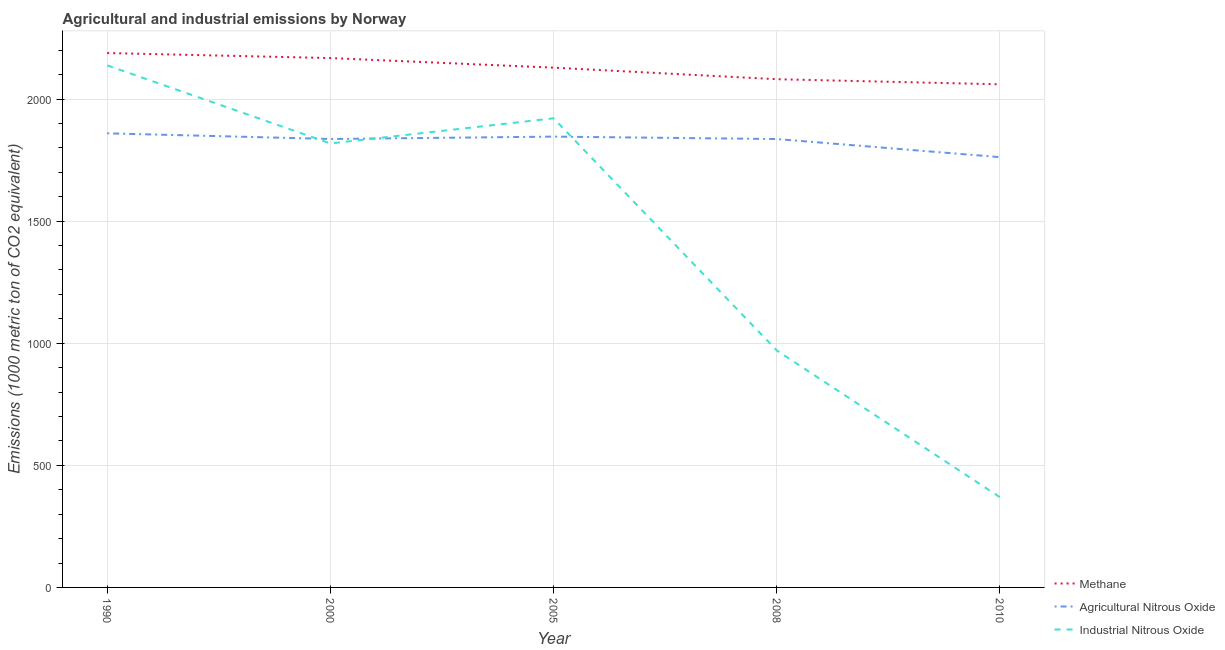Does the line corresponding to amount of agricultural nitrous oxide emissions intersect with the line corresponding to amount of methane emissions?
Provide a short and direct response. No. What is the amount of methane emissions in 2000?
Offer a terse response. 2167.9. Across all years, what is the maximum amount of industrial nitrous oxide emissions?
Your answer should be compact. 2138. Across all years, what is the minimum amount of methane emissions?
Give a very brief answer. 2060.5. In which year was the amount of industrial nitrous oxide emissions maximum?
Your response must be concise. 1990. In which year was the amount of methane emissions minimum?
Ensure brevity in your answer.  2010. What is the total amount of industrial nitrous oxide emissions in the graph?
Give a very brief answer. 7217.1. What is the difference between the amount of methane emissions in 1990 and that in 2005?
Your response must be concise. 59.9. What is the difference between the amount of agricultural nitrous oxide emissions in 2010 and the amount of methane emissions in 2000?
Your answer should be very brief. -405.8. What is the average amount of agricultural nitrous oxide emissions per year?
Your answer should be very brief. 1828.16. In the year 2000, what is the difference between the amount of industrial nitrous oxide emissions and amount of agricultural nitrous oxide emissions?
Your answer should be very brief. -18.3. In how many years, is the amount of agricultural nitrous oxide emissions greater than 400 metric ton?
Provide a succinct answer. 5. What is the ratio of the amount of industrial nitrous oxide emissions in 2005 to that in 2008?
Offer a very short reply. 1.98. Is the amount of methane emissions in 2005 less than that in 2010?
Your answer should be compact. No. What is the difference between the highest and the second highest amount of agricultural nitrous oxide emissions?
Your response must be concise. 13.5. What is the difference between the highest and the lowest amount of agricultural nitrous oxide emissions?
Offer a terse response. 97.6. Is it the case that in every year, the sum of the amount of methane emissions and amount of agricultural nitrous oxide emissions is greater than the amount of industrial nitrous oxide emissions?
Offer a very short reply. Yes. Does the graph contain grids?
Your response must be concise. Yes. Where does the legend appear in the graph?
Your answer should be compact. Bottom right. How many legend labels are there?
Provide a short and direct response. 3. How are the legend labels stacked?
Keep it short and to the point. Vertical. What is the title of the graph?
Offer a terse response. Agricultural and industrial emissions by Norway. What is the label or title of the Y-axis?
Your answer should be compact. Emissions (1000 metric ton of CO2 equivalent). What is the Emissions (1000 metric ton of CO2 equivalent) in Methane in 1990?
Ensure brevity in your answer.  2188.5. What is the Emissions (1000 metric ton of CO2 equivalent) of Agricultural Nitrous Oxide in 1990?
Offer a terse response. 1859.7. What is the Emissions (1000 metric ton of CO2 equivalent) of Industrial Nitrous Oxide in 1990?
Provide a succinct answer. 2138. What is the Emissions (1000 metric ton of CO2 equivalent) of Methane in 2000?
Keep it short and to the point. 2167.9. What is the Emissions (1000 metric ton of CO2 equivalent) in Agricultural Nitrous Oxide in 2000?
Offer a terse response. 1836.5. What is the Emissions (1000 metric ton of CO2 equivalent) of Industrial Nitrous Oxide in 2000?
Provide a short and direct response. 1818.2. What is the Emissions (1000 metric ton of CO2 equivalent) of Methane in 2005?
Offer a very short reply. 2128.6. What is the Emissions (1000 metric ton of CO2 equivalent) in Agricultural Nitrous Oxide in 2005?
Offer a terse response. 1846.2. What is the Emissions (1000 metric ton of CO2 equivalent) in Industrial Nitrous Oxide in 2005?
Make the answer very short. 1921.2. What is the Emissions (1000 metric ton of CO2 equivalent) in Methane in 2008?
Your answer should be very brief. 2081.3. What is the Emissions (1000 metric ton of CO2 equivalent) of Agricultural Nitrous Oxide in 2008?
Provide a short and direct response. 1836.3. What is the Emissions (1000 metric ton of CO2 equivalent) in Industrial Nitrous Oxide in 2008?
Offer a terse response. 970.4. What is the Emissions (1000 metric ton of CO2 equivalent) of Methane in 2010?
Offer a terse response. 2060.5. What is the Emissions (1000 metric ton of CO2 equivalent) in Agricultural Nitrous Oxide in 2010?
Offer a very short reply. 1762.1. What is the Emissions (1000 metric ton of CO2 equivalent) in Industrial Nitrous Oxide in 2010?
Your answer should be very brief. 369.3. Across all years, what is the maximum Emissions (1000 metric ton of CO2 equivalent) in Methane?
Ensure brevity in your answer.  2188.5. Across all years, what is the maximum Emissions (1000 metric ton of CO2 equivalent) of Agricultural Nitrous Oxide?
Give a very brief answer. 1859.7. Across all years, what is the maximum Emissions (1000 metric ton of CO2 equivalent) in Industrial Nitrous Oxide?
Give a very brief answer. 2138. Across all years, what is the minimum Emissions (1000 metric ton of CO2 equivalent) of Methane?
Your response must be concise. 2060.5. Across all years, what is the minimum Emissions (1000 metric ton of CO2 equivalent) in Agricultural Nitrous Oxide?
Provide a succinct answer. 1762.1. Across all years, what is the minimum Emissions (1000 metric ton of CO2 equivalent) in Industrial Nitrous Oxide?
Provide a succinct answer. 369.3. What is the total Emissions (1000 metric ton of CO2 equivalent) in Methane in the graph?
Provide a succinct answer. 1.06e+04. What is the total Emissions (1000 metric ton of CO2 equivalent) in Agricultural Nitrous Oxide in the graph?
Offer a terse response. 9140.8. What is the total Emissions (1000 metric ton of CO2 equivalent) in Industrial Nitrous Oxide in the graph?
Offer a very short reply. 7217.1. What is the difference between the Emissions (1000 metric ton of CO2 equivalent) of Methane in 1990 and that in 2000?
Provide a succinct answer. 20.6. What is the difference between the Emissions (1000 metric ton of CO2 equivalent) in Agricultural Nitrous Oxide in 1990 and that in 2000?
Your answer should be compact. 23.2. What is the difference between the Emissions (1000 metric ton of CO2 equivalent) in Industrial Nitrous Oxide in 1990 and that in 2000?
Ensure brevity in your answer.  319.8. What is the difference between the Emissions (1000 metric ton of CO2 equivalent) of Methane in 1990 and that in 2005?
Keep it short and to the point. 59.9. What is the difference between the Emissions (1000 metric ton of CO2 equivalent) of Industrial Nitrous Oxide in 1990 and that in 2005?
Your answer should be compact. 216.8. What is the difference between the Emissions (1000 metric ton of CO2 equivalent) of Methane in 1990 and that in 2008?
Ensure brevity in your answer.  107.2. What is the difference between the Emissions (1000 metric ton of CO2 equivalent) of Agricultural Nitrous Oxide in 1990 and that in 2008?
Make the answer very short. 23.4. What is the difference between the Emissions (1000 metric ton of CO2 equivalent) of Industrial Nitrous Oxide in 1990 and that in 2008?
Give a very brief answer. 1167.6. What is the difference between the Emissions (1000 metric ton of CO2 equivalent) of Methane in 1990 and that in 2010?
Make the answer very short. 128. What is the difference between the Emissions (1000 metric ton of CO2 equivalent) in Agricultural Nitrous Oxide in 1990 and that in 2010?
Give a very brief answer. 97.6. What is the difference between the Emissions (1000 metric ton of CO2 equivalent) of Industrial Nitrous Oxide in 1990 and that in 2010?
Offer a very short reply. 1768.7. What is the difference between the Emissions (1000 metric ton of CO2 equivalent) in Methane in 2000 and that in 2005?
Ensure brevity in your answer.  39.3. What is the difference between the Emissions (1000 metric ton of CO2 equivalent) of Industrial Nitrous Oxide in 2000 and that in 2005?
Provide a short and direct response. -103. What is the difference between the Emissions (1000 metric ton of CO2 equivalent) in Methane in 2000 and that in 2008?
Offer a terse response. 86.6. What is the difference between the Emissions (1000 metric ton of CO2 equivalent) of Industrial Nitrous Oxide in 2000 and that in 2008?
Offer a very short reply. 847.8. What is the difference between the Emissions (1000 metric ton of CO2 equivalent) in Methane in 2000 and that in 2010?
Offer a very short reply. 107.4. What is the difference between the Emissions (1000 metric ton of CO2 equivalent) of Agricultural Nitrous Oxide in 2000 and that in 2010?
Make the answer very short. 74.4. What is the difference between the Emissions (1000 metric ton of CO2 equivalent) of Industrial Nitrous Oxide in 2000 and that in 2010?
Provide a succinct answer. 1448.9. What is the difference between the Emissions (1000 metric ton of CO2 equivalent) of Methane in 2005 and that in 2008?
Give a very brief answer. 47.3. What is the difference between the Emissions (1000 metric ton of CO2 equivalent) in Agricultural Nitrous Oxide in 2005 and that in 2008?
Offer a very short reply. 9.9. What is the difference between the Emissions (1000 metric ton of CO2 equivalent) of Industrial Nitrous Oxide in 2005 and that in 2008?
Offer a terse response. 950.8. What is the difference between the Emissions (1000 metric ton of CO2 equivalent) in Methane in 2005 and that in 2010?
Provide a succinct answer. 68.1. What is the difference between the Emissions (1000 metric ton of CO2 equivalent) of Agricultural Nitrous Oxide in 2005 and that in 2010?
Your answer should be compact. 84.1. What is the difference between the Emissions (1000 metric ton of CO2 equivalent) of Industrial Nitrous Oxide in 2005 and that in 2010?
Give a very brief answer. 1551.9. What is the difference between the Emissions (1000 metric ton of CO2 equivalent) in Methane in 2008 and that in 2010?
Give a very brief answer. 20.8. What is the difference between the Emissions (1000 metric ton of CO2 equivalent) in Agricultural Nitrous Oxide in 2008 and that in 2010?
Ensure brevity in your answer.  74.2. What is the difference between the Emissions (1000 metric ton of CO2 equivalent) in Industrial Nitrous Oxide in 2008 and that in 2010?
Your answer should be very brief. 601.1. What is the difference between the Emissions (1000 metric ton of CO2 equivalent) of Methane in 1990 and the Emissions (1000 metric ton of CO2 equivalent) of Agricultural Nitrous Oxide in 2000?
Your answer should be compact. 352. What is the difference between the Emissions (1000 metric ton of CO2 equivalent) in Methane in 1990 and the Emissions (1000 metric ton of CO2 equivalent) in Industrial Nitrous Oxide in 2000?
Ensure brevity in your answer.  370.3. What is the difference between the Emissions (1000 metric ton of CO2 equivalent) in Agricultural Nitrous Oxide in 1990 and the Emissions (1000 metric ton of CO2 equivalent) in Industrial Nitrous Oxide in 2000?
Ensure brevity in your answer.  41.5. What is the difference between the Emissions (1000 metric ton of CO2 equivalent) in Methane in 1990 and the Emissions (1000 metric ton of CO2 equivalent) in Agricultural Nitrous Oxide in 2005?
Offer a terse response. 342.3. What is the difference between the Emissions (1000 metric ton of CO2 equivalent) of Methane in 1990 and the Emissions (1000 metric ton of CO2 equivalent) of Industrial Nitrous Oxide in 2005?
Your answer should be compact. 267.3. What is the difference between the Emissions (1000 metric ton of CO2 equivalent) of Agricultural Nitrous Oxide in 1990 and the Emissions (1000 metric ton of CO2 equivalent) of Industrial Nitrous Oxide in 2005?
Make the answer very short. -61.5. What is the difference between the Emissions (1000 metric ton of CO2 equivalent) in Methane in 1990 and the Emissions (1000 metric ton of CO2 equivalent) in Agricultural Nitrous Oxide in 2008?
Provide a short and direct response. 352.2. What is the difference between the Emissions (1000 metric ton of CO2 equivalent) of Methane in 1990 and the Emissions (1000 metric ton of CO2 equivalent) of Industrial Nitrous Oxide in 2008?
Provide a short and direct response. 1218.1. What is the difference between the Emissions (1000 metric ton of CO2 equivalent) of Agricultural Nitrous Oxide in 1990 and the Emissions (1000 metric ton of CO2 equivalent) of Industrial Nitrous Oxide in 2008?
Ensure brevity in your answer.  889.3. What is the difference between the Emissions (1000 metric ton of CO2 equivalent) of Methane in 1990 and the Emissions (1000 metric ton of CO2 equivalent) of Agricultural Nitrous Oxide in 2010?
Offer a very short reply. 426.4. What is the difference between the Emissions (1000 metric ton of CO2 equivalent) of Methane in 1990 and the Emissions (1000 metric ton of CO2 equivalent) of Industrial Nitrous Oxide in 2010?
Your response must be concise. 1819.2. What is the difference between the Emissions (1000 metric ton of CO2 equivalent) in Agricultural Nitrous Oxide in 1990 and the Emissions (1000 metric ton of CO2 equivalent) in Industrial Nitrous Oxide in 2010?
Your answer should be compact. 1490.4. What is the difference between the Emissions (1000 metric ton of CO2 equivalent) in Methane in 2000 and the Emissions (1000 metric ton of CO2 equivalent) in Agricultural Nitrous Oxide in 2005?
Your answer should be very brief. 321.7. What is the difference between the Emissions (1000 metric ton of CO2 equivalent) of Methane in 2000 and the Emissions (1000 metric ton of CO2 equivalent) of Industrial Nitrous Oxide in 2005?
Provide a short and direct response. 246.7. What is the difference between the Emissions (1000 metric ton of CO2 equivalent) of Agricultural Nitrous Oxide in 2000 and the Emissions (1000 metric ton of CO2 equivalent) of Industrial Nitrous Oxide in 2005?
Ensure brevity in your answer.  -84.7. What is the difference between the Emissions (1000 metric ton of CO2 equivalent) in Methane in 2000 and the Emissions (1000 metric ton of CO2 equivalent) in Agricultural Nitrous Oxide in 2008?
Your answer should be compact. 331.6. What is the difference between the Emissions (1000 metric ton of CO2 equivalent) of Methane in 2000 and the Emissions (1000 metric ton of CO2 equivalent) of Industrial Nitrous Oxide in 2008?
Give a very brief answer. 1197.5. What is the difference between the Emissions (1000 metric ton of CO2 equivalent) in Agricultural Nitrous Oxide in 2000 and the Emissions (1000 metric ton of CO2 equivalent) in Industrial Nitrous Oxide in 2008?
Provide a short and direct response. 866.1. What is the difference between the Emissions (1000 metric ton of CO2 equivalent) of Methane in 2000 and the Emissions (1000 metric ton of CO2 equivalent) of Agricultural Nitrous Oxide in 2010?
Keep it short and to the point. 405.8. What is the difference between the Emissions (1000 metric ton of CO2 equivalent) of Methane in 2000 and the Emissions (1000 metric ton of CO2 equivalent) of Industrial Nitrous Oxide in 2010?
Your answer should be very brief. 1798.6. What is the difference between the Emissions (1000 metric ton of CO2 equivalent) of Agricultural Nitrous Oxide in 2000 and the Emissions (1000 metric ton of CO2 equivalent) of Industrial Nitrous Oxide in 2010?
Offer a terse response. 1467.2. What is the difference between the Emissions (1000 metric ton of CO2 equivalent) in Methane in 2005 and the Emissions (1000 metric ton of CO2 equivalent) in Agricultural Nitrous Oxide in 2008?
Provide a short and direct response. 292.3. What is the difference between the Emissions (1000 metric ton of CO2 equivalent) of Methane in 2005 and the Emissions (1000 metric ton of CO2 equivalent) of Industrial Nitrous Oxide in 2008?
Provide a short and direct response. 1158.2. What is the difference between the Emissions (1000 metric ton of CO2 equivalent) in Agricultural Nitrous Oxide in 2005 and the Emissions (1000 metric ton of CO2 equivalent) in Industrial Nitrous Oxide in 2008?
Your response must be concise. 875.8. What is the difference between the Emissions (1000 metric ton of CO2 equivalent) of Methane in 2005 and the Emissions (1000 metric ton of CO2 equivalent) of Agricultural Nitrous Oxide in 2010?
Make the answer very short. 366.5. What is the difference between the Emissions (1000 metric ton of CO2 equivalent) of Methane in 2005 and the Emissions (1000 metric ton of CO2 equivalent) of Industrial Nitrous Oxide in 2010?
Provide a succinct answer. 1759.3. What is the difference between the Emissions (1000 metric ton of CO2 equivalent) of Agricultural Nitrous Oxide in 2005 and the Emissions (1000 metric ton of CO2 equivalent) of Industrial Nitrous Oxide in 2010?
Provide a short and direct response. 1476.9. What is the difference between the Emissions (1000 metric ton of CO2 equivalent) of Methane in 2008 and the Emissions (1000 metric ton of CO2 equivalent) of Agricultural Nitrous Oxide in 2010?
Give a very brief answer. 319.2. What is the difference between the Emissions (1000 metric ton of CO2 equivalent) in Methane in 2008 and the Emissions (1000 metric ton of CO2 equivalent) in Industrial Nitrous Oxide in 2010?
Make the answer very short. 1712. What is the difference between the Emissions (1000 metric ton of CO2 equivalent) in Agricultural Nitrous Oxide in 2008 and the Emissions (1000 metric ton of CO2 equivalent) in Industrial Nitrous Oxide in 2010?
Make the answer very short. 1467. What is the average Emissions (1000 metric ton of CO2 equivalent) of Methane per year?
Your answer should be very brief. 2125.36. What is the average Emissions (1000 metric ton of CO2 equivalent) in Agricultural Nitrous Oxide per year?
Your answer should be compact. 1828.16. What is the average Emissions (1000 metric ton of CO2 equivalent) in Industrial Nitrous Oxide per year?
Your answer should be compact. 1443.42. In the year 1990, what is the difference between the Emissions (1000 metric ton of CO2 equivalent) in Methane and Emissions (1000 metric ton of CO2 equivalent) in Agricultural Nitrous Oxide?
Your answer should be very brief. 328.8. In the year 1990, what is the difference between the Emissions (1000 metric ton of CO2 equivalent) of Methane and Emissions (1000 metric ton of CO2 equivalent) of Industrial Nitrous Oxide?
Your answer should be very brief. 50.5. In the year 1990, what is the difference between the Emissions (1000 metric ton of CO2 equivalent) in Agricultural Nitrous Oxide and Emissions (1000 metric ton of CO2 equivalent) in Industrial Nitrous Oxide?
Offer a terse response. -278.3. In the year 2000, what is the difference between the Emissions (1000 metric ton of CO2 equivalent) of Methane and Emissions (1000 metric ton of CO2 equivalent) of Agricultural Nitrous Oxide?
Keep it short and to the point. 331.4. In the year 2000, what is the difference between the Emissions (1000 metric ton of CO2 equivalent) in Methane and Emissions (1000 metric ton of CO2 equivalent) in Industrial Nitrous Oxide?
Your response must be concise. 349.7. In the year 2000, what is the difference between the Emissions (1000 metric ton of CO2 equivalent) of Agricultural Nitrous Oxide and Emissions (1000 metric ton of CO2 equivalent) of Industrial Nitrous Oxide?
Your response must be concise. 18.3. In the year 2005, what is the difference between the Emissions (1000 metric ton of CO2 equivalent) of Methane and Emissions (1000 metric ton of CO2 equivalent) of Agricultural Nitrous Oxide?
Give a very brief answer. 282.4. In the year 2005, what is the difference between the Emissions (1000 metric ton of CO2 equivalent) of Methane and Emissions (1000 metric ton of CO2 equivalent) of Industrial Nitrous Oxide?
Ensure brevity in your answer.  207.4. In the year 2005, what is the difference between the Emissions (1000 metric ton of CO2 equivalent) of Agricultural Nitrous Oxide and Emissions (1000 metric ton of CO2 equivalent) of Industrial Nitrous Oxide?
Ensure brevity in your answer.  -75. In the year 2008, what is the difference between the Emissions (1000 metric ton of CO2 equivalent) of Methane and Emissions (1000 metric ton of CO2 equivalent) of Agricultural Nitrous Oxide?
Give a very brief answer. 245. In the year 2008, what is the difference between the Emissions (1000 metric ton of CO2 equivalent) of Methane and Emissions (1000 metric ton of CO2 equivalent) of Industrial Nitrous Oxide?
Offer a terse response. 1110.9. In the year 2008, what is the difference between the Emissions (1000 metric ton of CO2 equivalent) in Agricultural Nitrous Oxide and Emissions (1000 metric ton of CO2 equivalent) in Industrial Nitrous Oxide?
Your answer should be compact. 865.9. In the year 2010, what is the difference between the Emissions (1000 metric ton of CO2 equivalent) of Methane and Emissions (1000 metric ton of CO2 equivalent) of Agricultural Nitrous Oxide?
Keep it short and to the point. 298.4. In the year 2010, what is the difference between the Emissions (1000 metric ton of CO2 equivalent) in Methane and Emissions (1000 metric ton of CO2 equivalent) in Industrial Nitrous Oxide?
Give a very brief answer. 1691.2. In the year 2010, what is the difference between the Emissions (1000 metric ton of CO2 equivalent) of Agricultural Nitrous Oxide and Emissions (1000 metric ton of CO2 equivalent) of Industrial Nitrous Oxide?
Your answer should be compact. 1392.8. What is the ratio of the Emissions (1000 metric ton of CO2 equivalent) in Methane in 1990 to that in 2000?
Your answer should be compact. 1.01. What is the ratio of the Emissions (1000 metric ton of CO2 equivalent) in Agricultural Nitrous Oxide in 1990 to that in 2000?
Offer a terse response. 1.01. What is the ratio of the Emissions (1000 metric ton of CO2 equivalent) in Industrial Nitrous Oxide in 1990 to that in 2000?
Give a very brief answer. 1.18. What is the ratio of the Emissions (1000 metric ton of CO2 equivalent) of Methane in 1990 to that in 2005?
Make the answer very short. 1.03. What is the ratio of the Emissions (1000 metric ton of CO2 equivalent) in Agricultural Nitrous Oxide in 1990 to that in 2005?
Provide a succinct answer. 1.01. What is the ratio of the Emissions (1000 metric ton of CO2 equivalent) of Industrial Nitrous Oxide in 1990 to that in 2005?
Give a very brief answer. 1.11. What is the ratio of the Emissions (1000 metric ton of CO2 equivalent) of Methane in 1990 to that in 2008?
Keep it short and to the point. 1.05. What is the ratio of the Emissions (1000 metric ton of CO2 equivalent) in Agricultural Nitrous Oxide in 1990 to that in 2008?
Provide a short and direct response. 1.01. What is the ratio of the Emissions (1000 metric ton of CO2 equivalent) of Industrial Nitrous Oxide in 1990 to that in 2008?
Your answer should be very brief. 2.2. What is the ratio of the Emissions (1000 metric ton of CO2 equivalent) in Methane in 1990 to that in 2010?
Your answer should be compact. 1.06. What is the ratio of the Emissions (1000 metric ton of CO2 equivalent) in Agricultural Nitrous Oxide in 1990 to that in 2010?
Your answer should be compact. 1.06. What is the ratio of the Emissions (1000 metric ton of CO2 equivalent) in Industrial Nitrous Oxide in 1990 to that in 2010?
Ensure brevity in your answer.  5.79. What is the ratio of the Emissions (1000 metric ton of CO2 equivalent) of Methane in 2000 to that in 2005?
Provide a succinct answer. 1.02. What is the ratio of the Emissions (1000 metric ton of CO2 equivalent) of Industrial Nitrous Oxide in 2000 to that in 2005?
Offer a very short reply. 0.95. What is the ratio of the Emissions (1000 metric ton of CO2 equivalent) of Methane in 2000 to that in 2008?
Offer a terse response. 1.04. What is the ratio of the Emissions (1000 metric ton of CO2 equivalent) in Agricultural Nitrous Oxide in 2000 to that in 2008?
Your response must be concise. 1. What is the ratio of the Emissions (1000 metric ton of CO2 equivalent) in Industrial Nitrous Oxide in 2000 to that in 2008?
Ensure brevity in your answer.  1.87. What is the ratio of the Emissions (1000 metric ton of CO2 equivalent) of Methane in 2000 to that in 2010?
Offer a very short reply. 1.05. What is the ratio of the Emissions (1000 metric ton of CO2 equivalent) of Agricultural Nitrous Oxide in 2000 to that in 2010?
Offer a very short reply. 1.04. What is the ratio of the Emissions (1000 metric ton of CO2 equivalent) in Industrial Nitrous Oxide in 2000 to that in 2010?
Your answer should be compact. 4.92. What is the ratio of the Emissions (1000 metric ton of CO2 equivalent) of Methane in 2005 to that in 2008?
Make the answer very short. 1.02. What is the ratio of the Emissions (1000 metric ton of CO2 equivalent) in Agricultural Nitrous Oxide in 2005 to that in 2008?
Offer a terse response. 1.01. What is the ratio of the Emissions (1000 metric ton of CO2 equivalent) in Industrial Nitrous Oxide in 2005 to that in 2008?
Provide a succinct answer. 1.98. What is the ratio of the Emissions (1000 metric ton of CO2 equivalent) in Methane in 2005 to that in 2010?
Ensure brevity in your answer.  1.03. What is the ratio of the Emissions (1000 metric ton of CO2 equivalent) in Agricultural Nitrous Oxide in 2005 to that in 2010?
Your answer should be very brief. 1.05. What is the ratio of the Emissions (1000 metric ton of CO2 equivalent) in Industrial Nitrous Oxide in 2005 to that in 2010?
Give a very brief answer. 5.2. What is the ratio of the Emissions (1000 metric ton of CO2 equivalent) of Agricultural Nitrous Oxide in 2008 to that in 2010?
Ensure brevity in your answer.  1.04. What is the ratio of the Emissions (1000 metric ton of CO2 equivalent) of Industrial Nitrous Oxide in 2008 to that in 2010?
Keep it short and to the point. 2.63. What is the difference between the highest and the second highest Emissions (1000 metric ton of CO2 equivalent) in Methane?
Offer a terse response. 20.6. What is the difference between the highest and the second highest Emissions (1000 metric ton of CO2 equivalent) of Agricultural Nitrous Oxide?
Your response must be concise. 13.5. What is the difference between the highest and the second highest Emissions (1000 metric ton of CO2 equivalent) in Industrial Nitrous Oxide?
Keep it short and to the point. 216.8. What is the difference between the highest and the lowest Emissions (1000 metric ton of CO2 equivalent) of Methane?
Offer a very short reply. 128. What is the difference between the highest and the lowest Emissions (1000 metric ton of CO2 equivalent) in Agricultural Nitrous Oxide?
Your answer should be compact. 97.6. What is the difference between the highest and the lowest Emissions (1000 metric ton of CO2 equivalent) in Industrial Nitrous Oxide?
Your answer should be compact. 1768.7. 